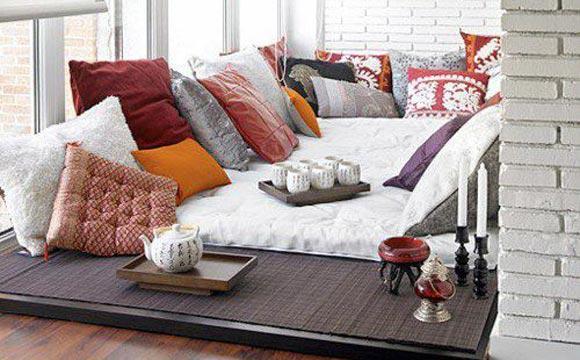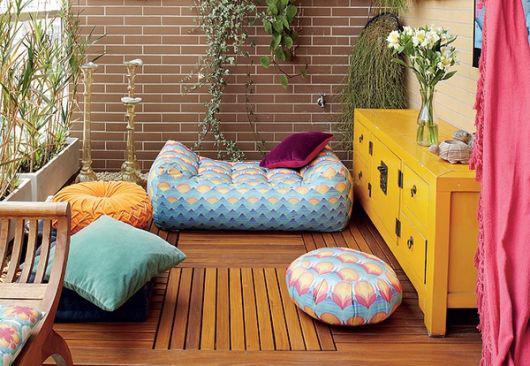The first image is the image on the left, the second image is the image on the right. Assess this claim about the two images: "An image shows a room featuring bright yellowish furniture.". Correct or not? Answer yes or no. Yes. 